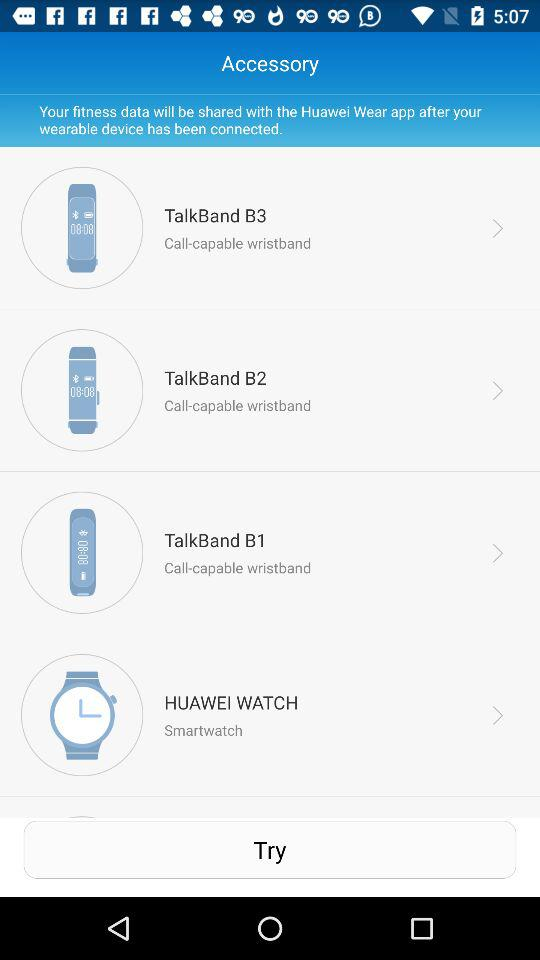What are the different types of Huawei accessories shown on the screen? The different types of Huawei accessories shown on the screen are "TalkBand B3", "TalkBand B2", "TalkBand B1" and "HUAWEI WATCH". 